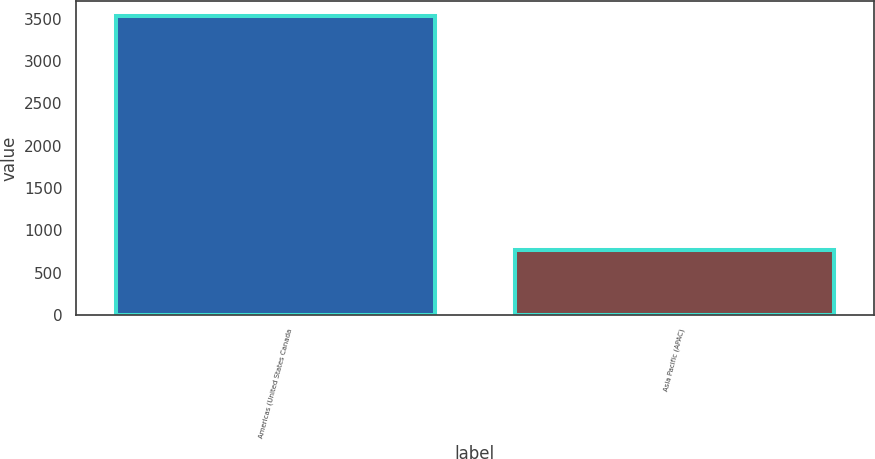Convert chart to OTSL. <chart><loc_0><loc_0><loc_500><loc_500><bar_chart><fcel>Americas (United States Canada<fcel>Asia Pacific (APAC)<nl><fcel>3529.7<fcel>767<nl></chart> 